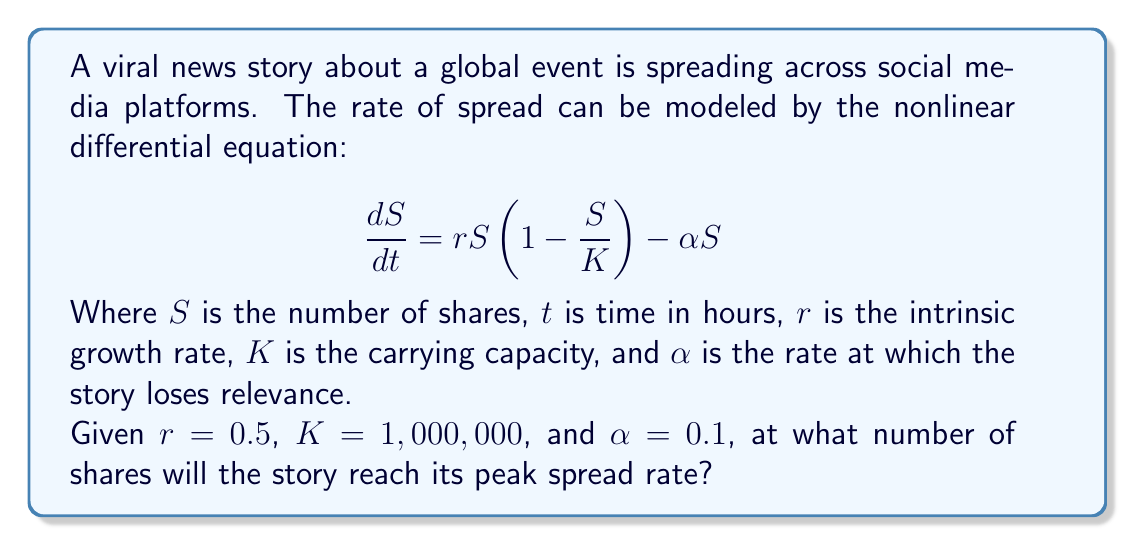Show me your answer to this math problem. To find the number of shares at which the story reaches its peak spread rate, we need to find the maximum of the rate function. Let's approach this step-by-step:

1) First, let's expand the differential equation:

   $$\frac{dS}{dt} = rS - \frac{rS^2}{K} - \alpha S$$

2) Now, we can factor out $S$:

   $$\frac{dS}{dt} = S(r - \frac{rS}{K} - \alpha)$$

3) To find the maximum rate, we need to differentiate this with respect to $S$ and set it to zero:

   $$\frac{d}{dS}(\frac{dS}{dt}) = r - \frac{2rS}{K} - \alpha = 0$$

4) Solve this equation for $S$:

   $$r - \frac{2rS}{K} - \alpha = 0$$
   $$r - \alpha = \frac{2rS}{K}$$
   $$\frac{K(r - \alpha)}{2r} = S$$

5) Now we can plug in our given values:

   $$S = \frac{1,000,000(0.5 - 0.1)}{2(0.5)} = \frac{1,000,000(0.4)}{1} = 400,000$$

Therefore, the story will reach its peak spread rate when it has been shared 400,000 times.
Answer: 400,000 shares 